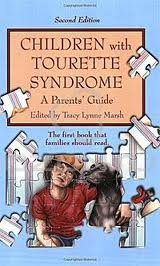Is this a fitness book? The book is not exactly a fitness book; instead, it offers health management strategies for families dealing with Tourette Syndrome. 